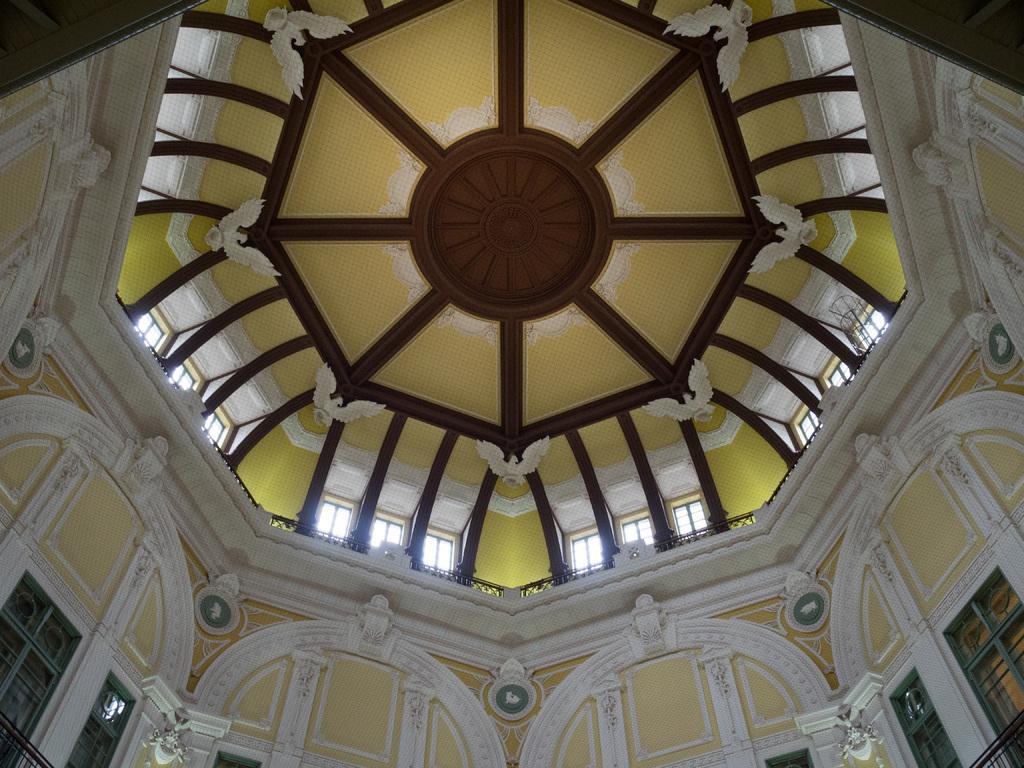How would you summarize this image in a sentence or two? In this picture there is a roof with sculptures, doors and windows. 